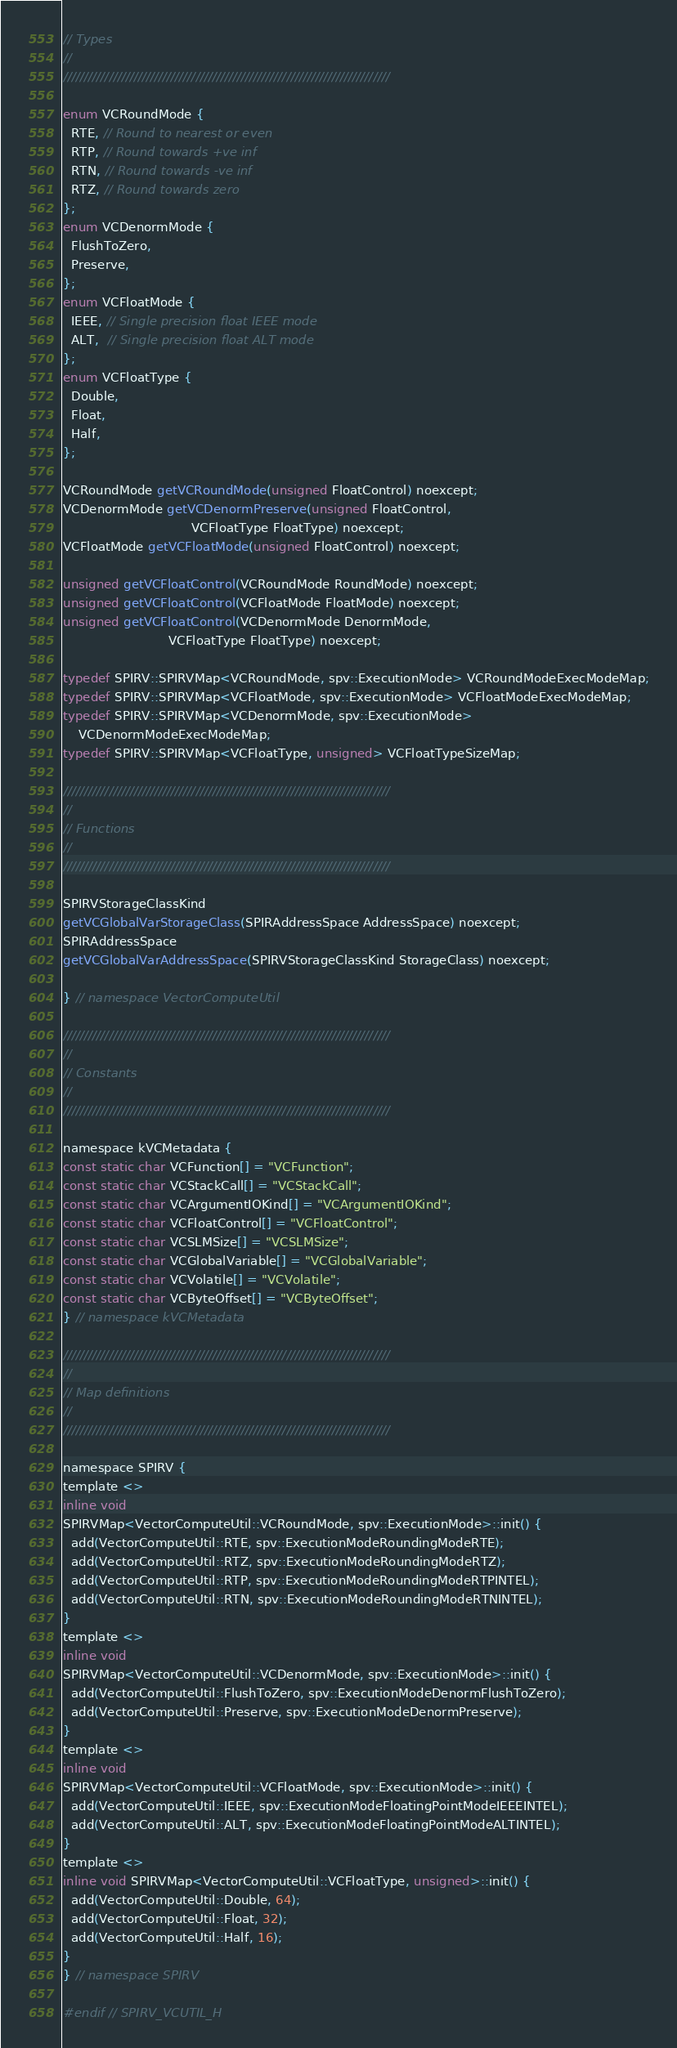<code> <loc_0><loc_0><loc_500><loc_500><_C_>// Types
//
///////////////////////////////////////////////////////////////////////////////

enum VCRoundMode {
  RTE, // Round to nearest or even
  RTP, // Round towards +ve inf
  RTN, // Round towards -ve inf
  RTZ, // Round towards zero
};
enum VCDenormMode {
  FlushToZero,
  Preserve,
};
enum VCFloatMode {
  IEEE, // Single precision float IEEE mode
  ALT,  // Single precision float ALT mode
};
enum VCFloatType {
  Double,
  Float,
  Half,
};

VCRoundMode getVCRoundMode(unsigned FloatControl) noexcept;
VCDenormMode getVCDenormPreserve(unsigned FloatControl,
                                 VCFloatType FloatType) noexcept;
VCFloatMode getVCFloatMode(unsigned FloatControl) noexcept;

unsigned getVCFloatControl(VCRoundMode RoundMode) noexcept;
unsigned getVCFloatControl(VCFloatMode FloatMode) noexcept;
unsigned getVCFloatControl(VCDenormMode DenormMode,
                           VCFloatType FloatType) noexcept;

typedef SPIRV::SPIRVMap<VCRoundMode, spv::ExecutionMode> VCRoundModeExecModeMap;
typedef SPIRV::SPIRVMap<VCFloatMode, spv::ExecutionMode> VCFloatModeExecModeMap;
typedef SPIRV::SPIRVMap<VCDenormMode, spv::ExecutionMode>
    VCDenormModeExecModeMap;
typedef SPIRV::SPIRVMap<VCFloatType, unsigned> VCFloatTypeSizeMap;

///////////////////////////////////////////////////////////////////////////////
//
// Functions
//
///////////////////////////////////////////////////////////////////////////////

SPIRVStorageClassKind
getVCGlobalVarStorageClass(SPIRAddressSpace AddressSpace) noexcept;
SPIRAddressSpace
getVCGlobalVarAddressSpace(SPIRVStorageClassKind StorageClass) noexcept;

} // namespace VectorComputeUtil

///////////////////////////////////////////////////////////////////////////////
//
// Constants
//
///////////////////////////////////////////////////////////////////////////////

namespace kVCMetadata {
const static char VCFunction[] = "VCFunction";
const static char VCStackCall[] = "VCStackCall";
const static char VCArgumentIOKind[] = "VCArgumentIOKind";
const static char VCFloatControl[] = "VCFloatControl";
const static char VCSLMSize[] = "VCSLMSize";
const static char VCGlobalVariable[] = "VCGlobalVariable";
const static char VCVolatile[] = "VCVolatile";
const static char VCByteOffset[] = "VCByteOffset";
} // namespace kVCMetadata

///////////////////////////////////////////////////////////////////////////////
//
// Map definitions
//
///////////////////////////////////////////////////////////////////////////////

namespace SPIRV {
template <>
inline void
SPIRVMap<VectorComputeUtil::VCRoundMode, spv::ExecutionMode>::init() {
  add(VectorComputeUtil::RTE, spv::ExecutionModeRoundingModeRTE);
  add(VectorComputeUtil::RTZ, spv::ExecutionModeRoundingModeRTZ);
  add(VectorComputeUtil::RTP, spv::ExecutionModeRoundingModeRTPINTEL);
  add(VectorComputeUtil::RTN, spv::ExecutionModeRoundingModeRTNINTEL);
}
template <>
inline void
SPIRVMap<VectorComputeUtil::VCDenormMode, spv::ExecutionMode>::init() {
  add(VectorComputeUtil::FlushToZero, spv::ExecutionModeDenormFlushToZero);
  add(VectorComputeUtil::Preserve, spv::ExecutionModeDenormPreserve);
}
template <>
inline void
SPIRVMap<VectorComputeUtil::VCFloatMode, spv::ExecutionMode>::init() {
  add(VectorComputeUtil::IEEE, spv::ExecutionModeFloatingPointModeIEEEINTEL);
  add(VectorComputeUtil::ALT, spv::ExecutionModeFloatingPointModeALTINTEL);
}
template <>
inline void SPIRVMap<VectorComputeUtil::VCFloatType, unsigned>::init() {
  add(VectorComputeUtil::Double, 64);
  add(VectorComputeUtil::Float, 32);
  add(VectorComputeUtil::Half, 16);
}
} // namespace SPIRV

#endif // SPIRV_VCUTIL_H
</code> 